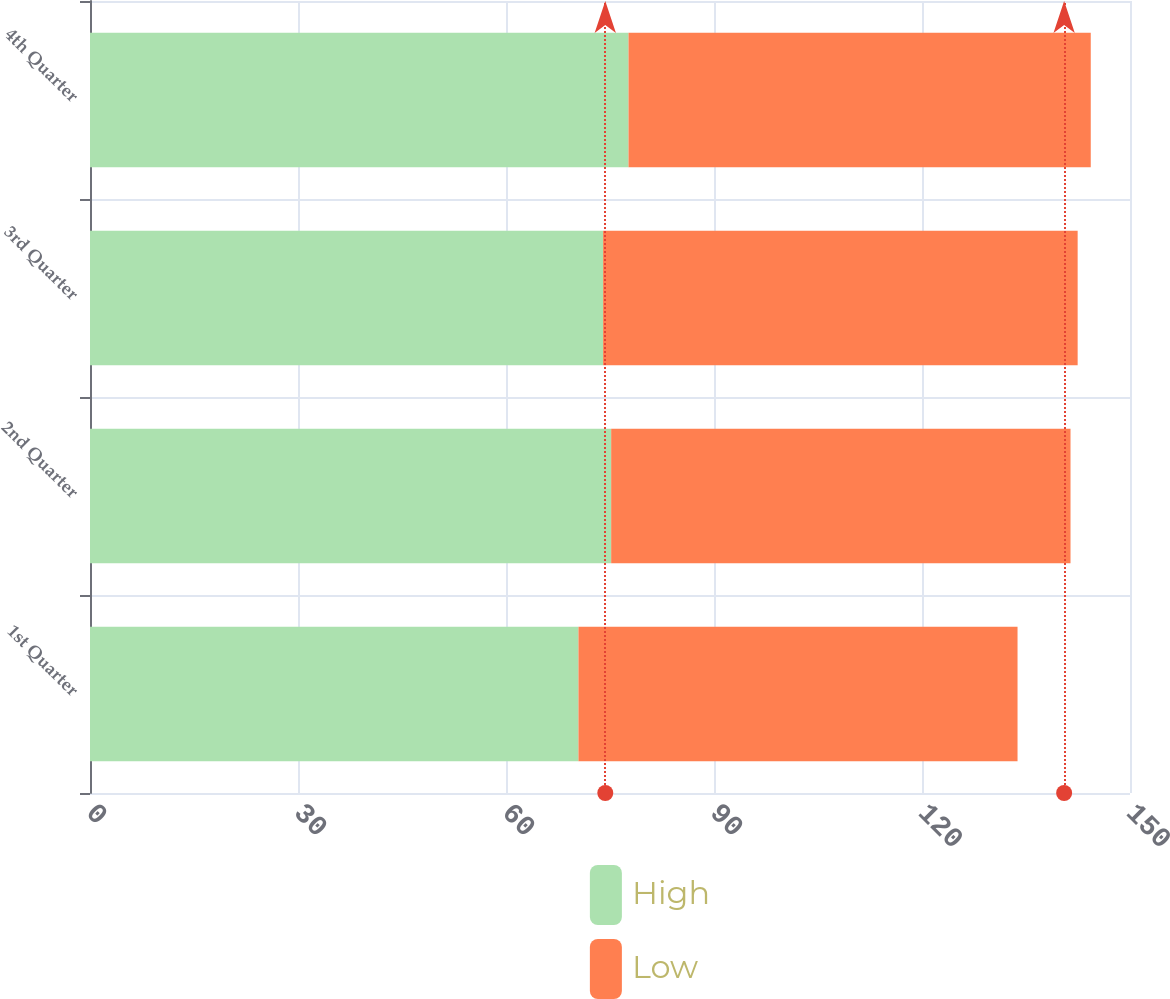<chart> <loc_0><loc_0><loc_500><loc_500><stacked_bar_chart><ecel><fcel>1st Quarter<fcel>2nd Quarter<fcel>3rd Quarter<fcel>4th Quarter<nl><fcel>High<fcel>70.45<fcel>75.17<fcel>74<fcel>77.67<nl><fcel>Low<fcel>63.33<fcel>66.25<fcel>68.45<fcel>66.67<nl></chart> 